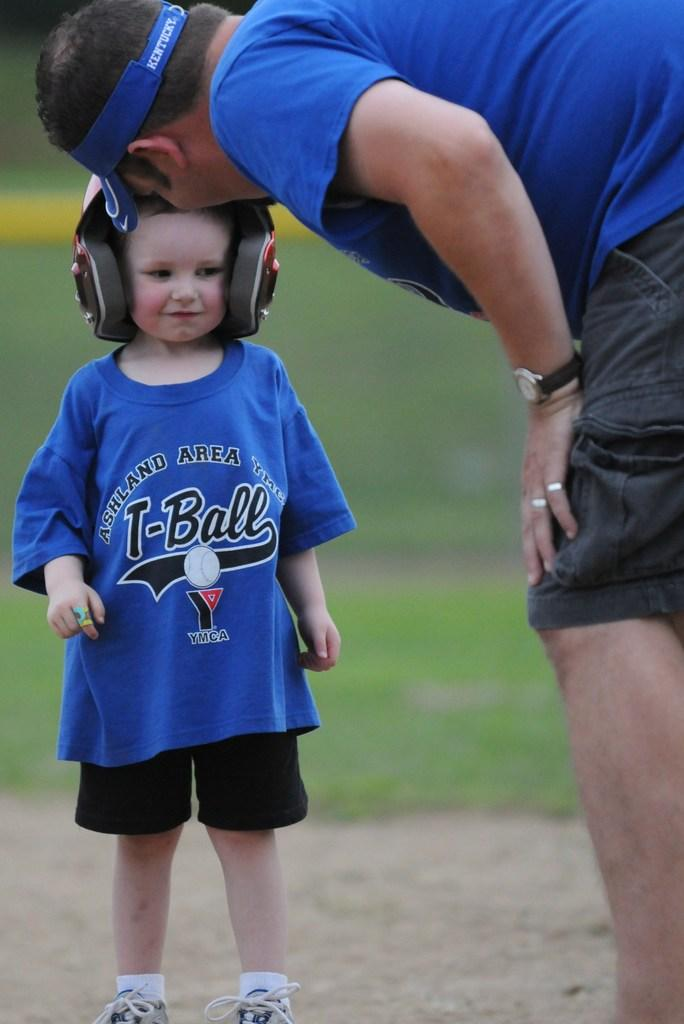Provide a one-sentence caption for the provided image. a man and a child in blue t shirts with ashland area written on them. 